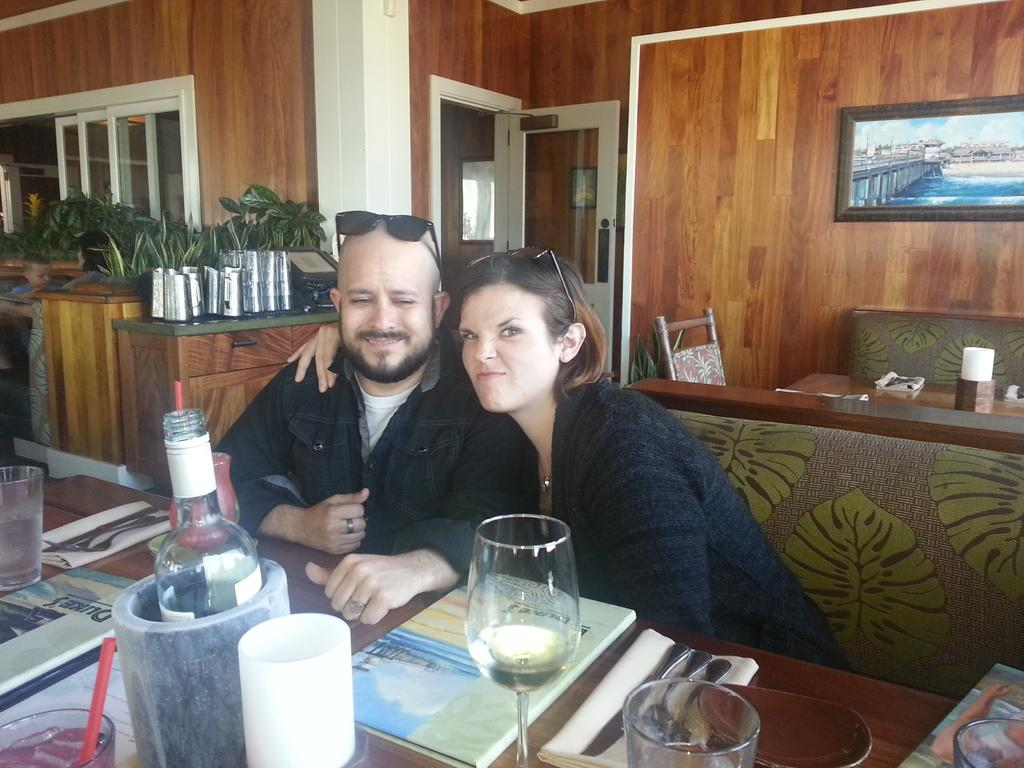Who is present in the image? There is a man and a woman in the image. What are they doing in the image? They are sitting on a sofa. What objects can be seen related to drinks? There are wine glasses and bottles in the image. What piece of furniture is visible in the image? There is a dining table in the image. What architectural feature is visible in the image? There is a door visible in the image. What type of bun is being served on the dining table in the image? There is no bun visible on the dining table in the image. What type of boundary is depicted in the image? There is no boundary depicted in the image; it is an indoor scene with a door. 